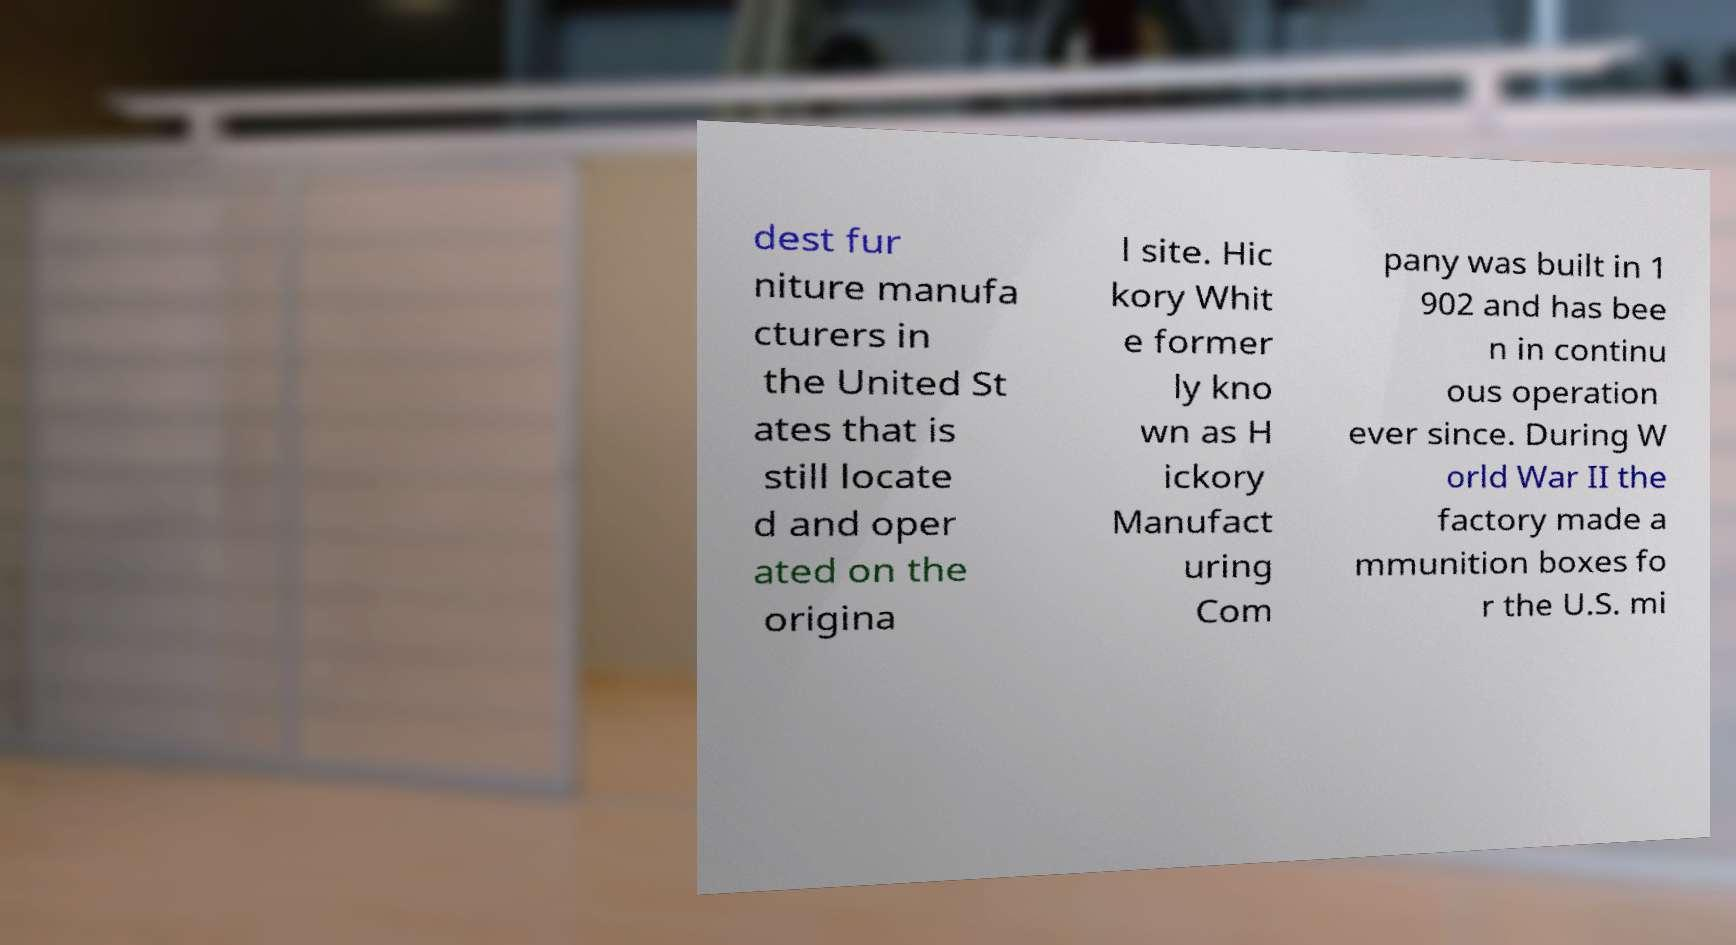For documentation purposes, I need the text within this image transcribed. Could you provide that? dest fur niture manufa cturers in the United St ates that is still locate d and oper ated on the origina l site. Hic kory Whit e former ly kno wn as H ickory Manufact uring Com pany was built in 1 902 and has bee n in continu ous operation ever since. During W orld War II the factory made a mmunition boxes fo r the U.S. mi 